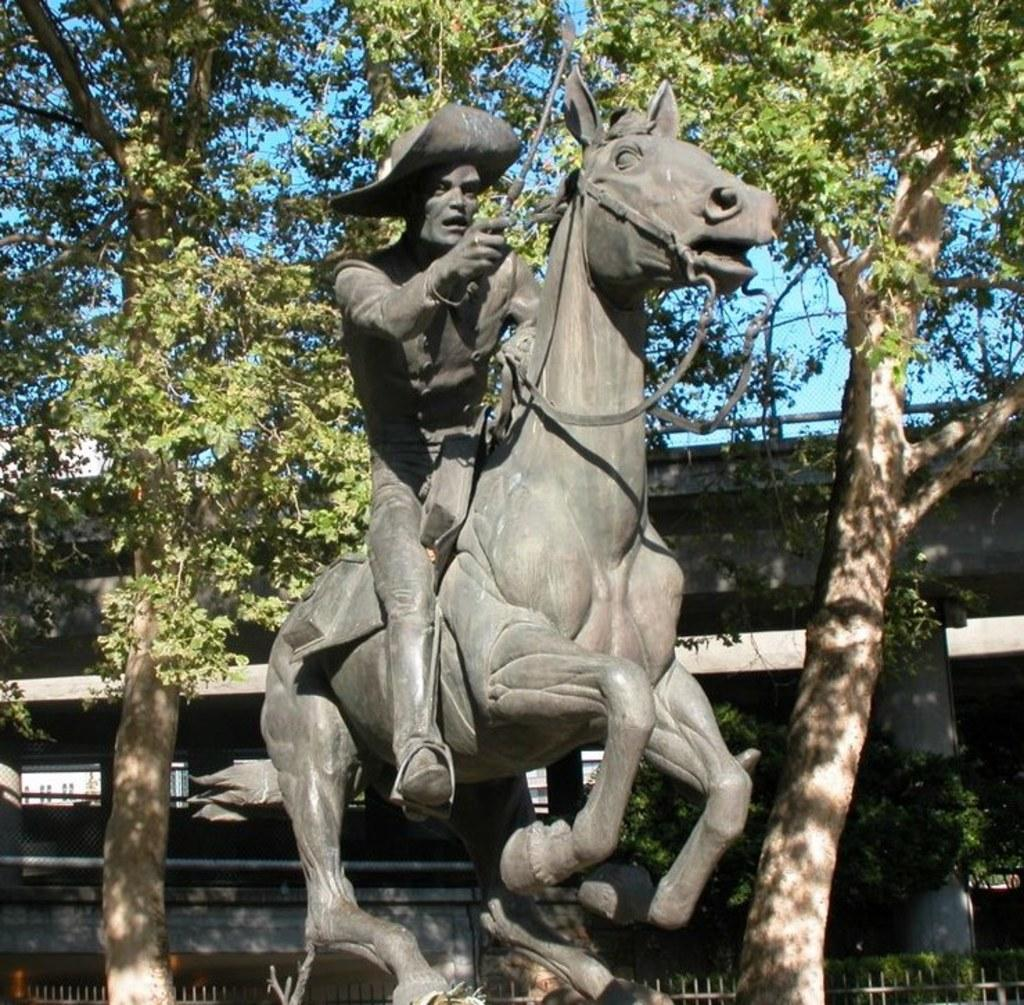What is the main subject in the image? There is a statue in the image. What can be seen in the background of the image? There are trees, plants, a building, walls, mesh, pillars, and the sky visible in the background of the image. What type of barrier is present at the bottom of the image? There is fencing at the bottom of the image. How does the plantation in the image provide shade for the statue? There is no plantation present in the image, and therefore no shade is provided for the statue. What type of mouth does the statue have in the image? The statue does not have a mouth, as it is a non-living object and does not possess human-like features. 